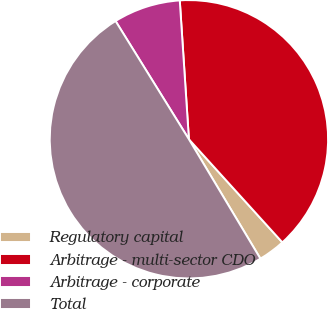Convert chart to OTSL. <chart><loc_0><loc_0><loc_500><loc_500><pie_chart><fcel>Regulatory capital<fcel>Arbitrage - multi-sector CDO<fcel>Arbitrage - corporate<fcel>Total<nl><fcel>3.13%<fcel>39.33%<fcel>7.79%<fcel>49.75%<nl></chart> 